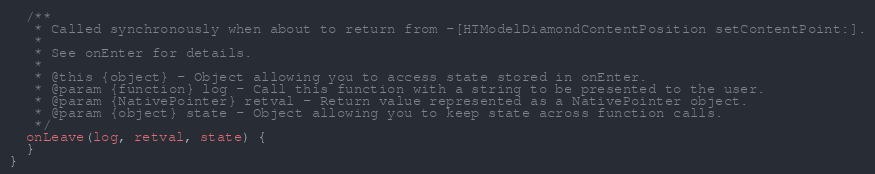<code> <loc_0><loc_0><loc_500><loc_500><_JavaScript_>
  /**
   * Called synchronously when about to return from -[HTModelDiamondContentPosition setContentPoint:].
   *
   * See onEnter for details.
   *
   * @this {object} - Object allowing you to access state stored in onEnter.
   * @param {function} log - Call this function with a string to be presented to the user.
   * @param {NativePointer} retval - Return value represented as a NativePointer object.
   * @param {object} state - Object allowing you to keep state across function calls.
   */
  onLeave(log, retval, state) {
  }
}
</code> 